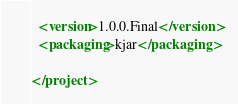<code> <loc_0><loc_0><loc_500><loc_500><_XML_>  <version>1.0.0.Final</version>
  <packaging>kjar</packaging>

</project>
</code> 